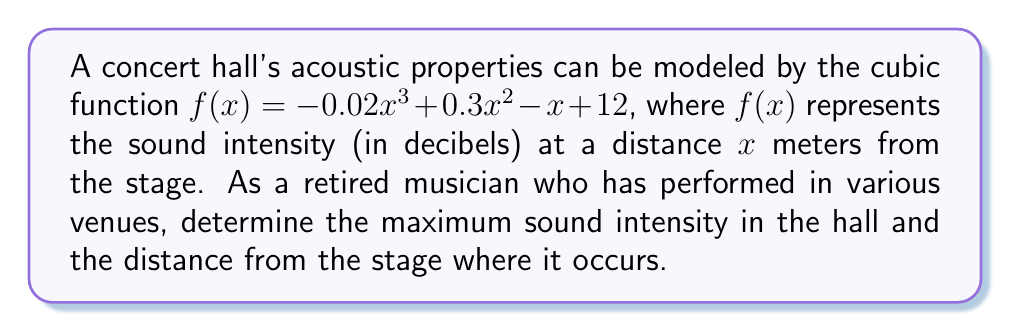Provide a solution to this math problem. To find the maximum sound intensity, we need to find the local maximum of the cubic function. This occurs where the derivative of the function is zero.

1) First, let's find the derivative of $f(x)$:
   $f'(x) = -0.06x^2 + 0.6x - 1$

2) Set the derivative equal to zero:
   $-0.06x^2 + 0.6x - 1 = 0$

3) This is a quadratic equation. We can solve it using the quadratic formula:
   $x = \frac{-b \pm \sqrt{b^2 - 4ac}}{2a}$

   Where $a = -0.06$, $b = 0.6$, and $c = -1$

4) Plugging in these values:
   $x = \frac{-0.6 \pm \sqrt{0.6^2 - 4(-0.06)(-1)}}{2(-0.06)}$
   $= \frac{-0.6 \pm \sqrt{0.36 - 0.24}}{-0.12}$
   $= \frac{-0.6 \pm \sqrt{0.12}}{-0.12}$
   $= \frac{-0.6 \pm 0.3464}{-0.12}$

5) This gives us two solutions:
   $x_1 = \frac{-0.6 + 0.3464}{-0.12} \approx 2.11$
   $x_2 = \frac{-0.6 - 0.3464}{-0.12} \approx 7.89$

6) The second solution (7.89) is outside the typical range for a concert hall, so we'll focus on $x \approx 2.11$ meters.

7) To find the maximum sound intensity, we plug this x-value back into our original function:
   $f(2.11) = -0.02(2.11)^3 + 0.3(2.11)^2 - 2.11 + 12 \approx 12.37$

Therefore, the maximum sound intensity is approximately 12.37 decibels, occurring at a distance of about 2.11 meters from the stage.
Answer: 12.37 dB at 2.11 m 